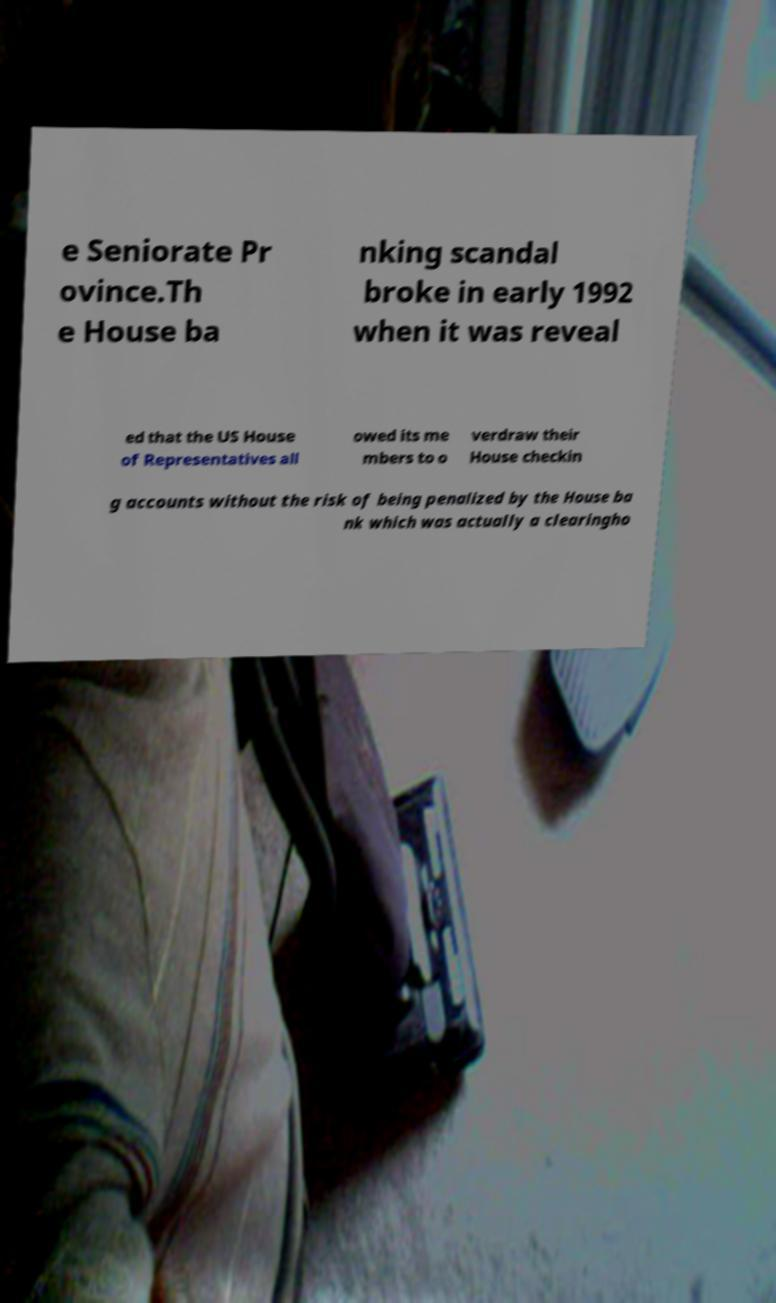Please read and relay the text visible in this image. What does it say? e Seniorate Pr ovince.Th e House ba nking scandal broke in early 1992 when it was reveal ed that the US House of Representatives all owed its me mbers to o verdraw their House checkin g accounts without the risk of being penalized by the House ba nk which was actually a clearingho 